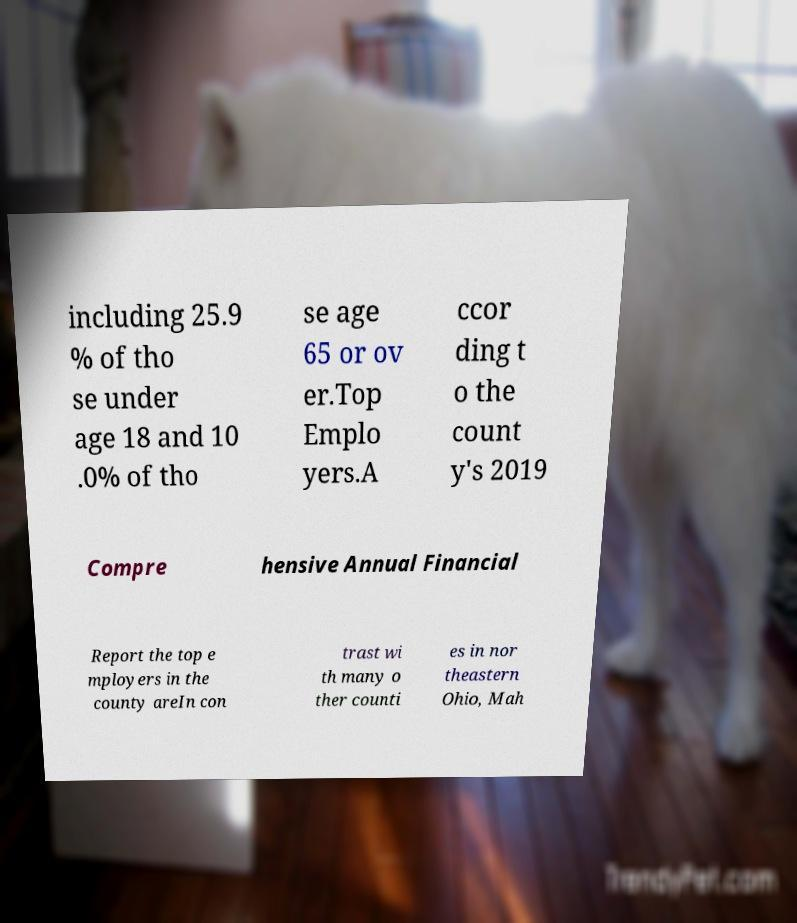What messages or text are displayed in this image? I need them in a readable, typed format. including 25.9 % of tho se under age 18 and 10 .0% of tho se age 65 or ov er.Top Emplo yers.A ccor ding t o the count y's 2019 Compre hensive Annual Financial Report the top e mployers in the county areIn con trast wi th many o ther counti es in nor theastern Ohio, Mah 